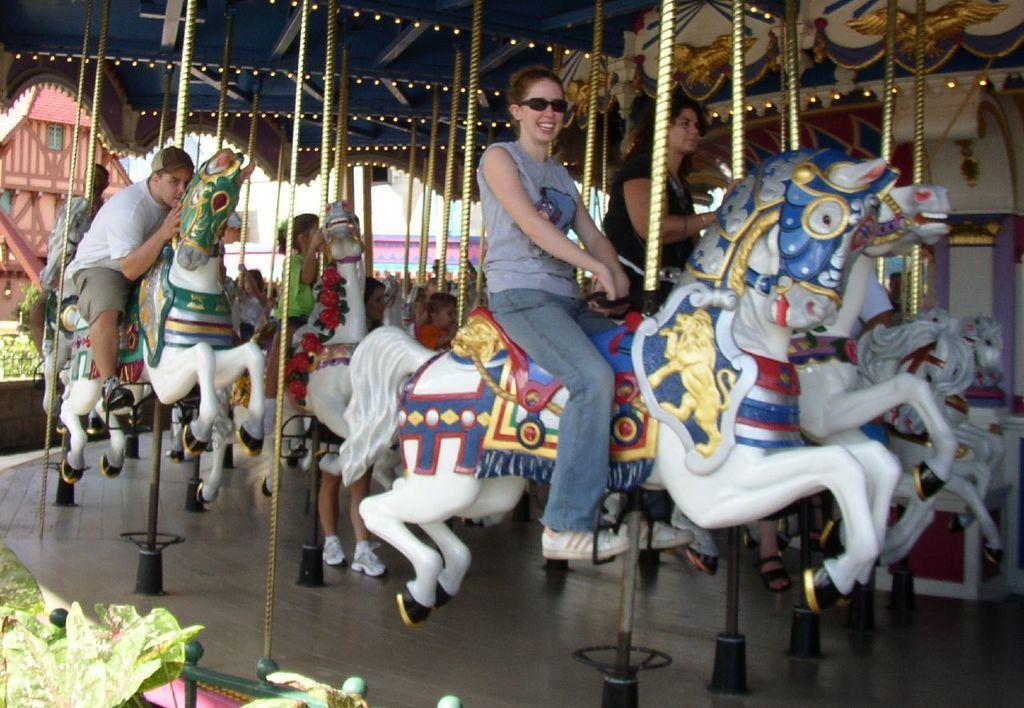Describe this image in one or two sentences. In this image we can see persons and children playing fun ride. In the background we can see plants and buildings. 